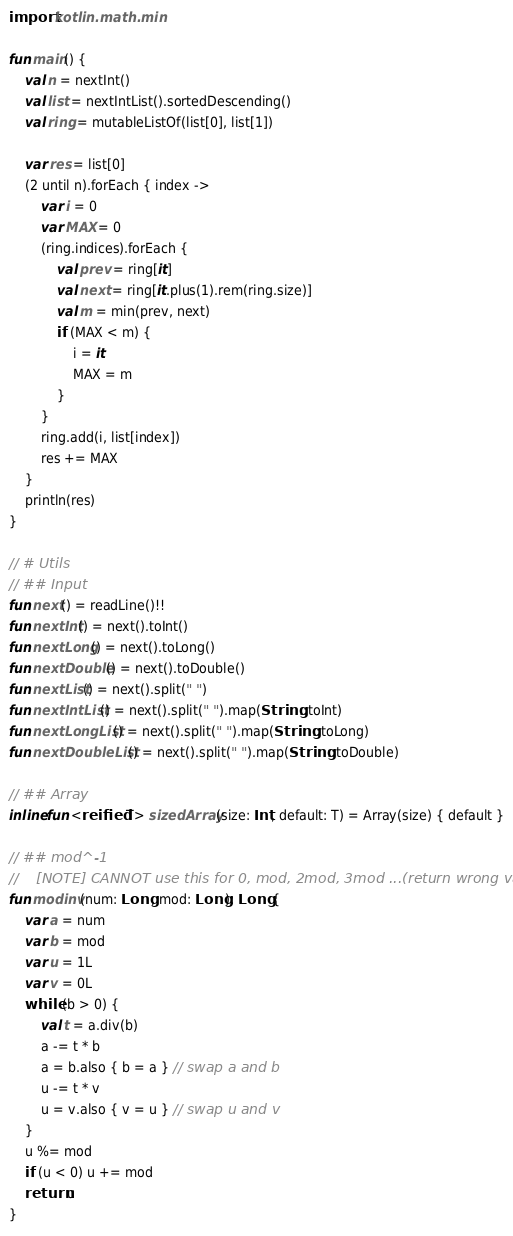<code> <loc_0><loc_0><loc_500><loc_500><_Kotlin_>import kotlin.math.min

fun main() {
    val n = nextInt()
    val list = nextIntList().sortedDescending()
    val ring = mutableListOf(list[0], list[1])

    var res = list[0]
    (2 until n).forEach { index ->
        var i = 0
        var MAX = 0
        (ring.indices).forEach {
            val prev = ring[it]
            val next = ring[it.plus(1).rem(ring.size)]
            val m = min(prev, next)
            if (MAX < m) {
                i = it
                MAX = m
            }
        }
        ring.add(i, list[index])
        res += MAX
    }
    println(res)
}

// # Utils
// ## Input
fun next() = readLine()!!
fun nextInt() = next().toInt()
fun nextLong() = next().toLong()
fun nextDouble() = next().toDouble()
fun nextList() = next().split(" ")
fun nextIntList() = next().split(" ").map(String::toInt)
fun nextLongList() = next().split(" ").map(String::toLong)
fun nextDoubleList() = next().split(" ").map(String::toDouble)

// ## Array
inline fun <reified T> sizedArray(size: Int, default: T) = Array(size) { default }

// ## mod^-1
//    [NOTE] CANNOT use this for 0, mod, 2mod, 3mod ...(return wrong value)
fun modinv(num: Long, mod: Long): Long {
    var a = num
    var b = mod
    var u = 1L
    var v = 0L
    while (b > 0) {
        val t = a.div(b)
        a -= t * b
        a = b.also { b = a } // swap a and b
        u -= t * v
        u = v.also { v = u } // swap u and v
    }
    u %= mod
    if (u < 0) u += mod
    return u
}</code> 